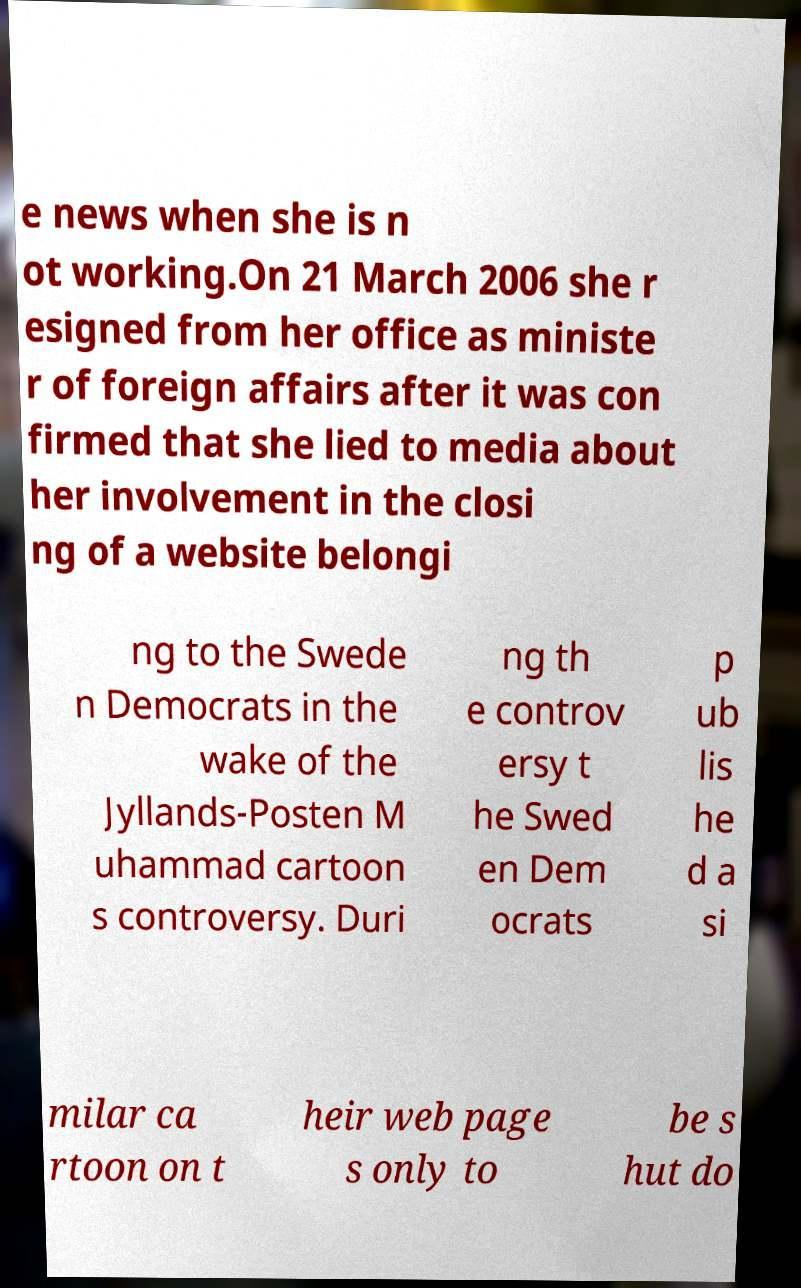What messages or text are displayed in this image? I need them in a readable, typed format. e news when she is n ot working.On 21 March 2006 she r esigned from her office as ministe r of foreign affairs after it was con firmed that she lied to media about her involvement in the closi ng of a website belongi ng to the Swede n Democrats in the wake of the Jyllands-Posten M uhammad cartoon s controversy. Duri ng th e controv ersy t he Swed en Dem ocrats p ub lis he d a si milar ca rtoon on t heir web page s only to be s hut do 